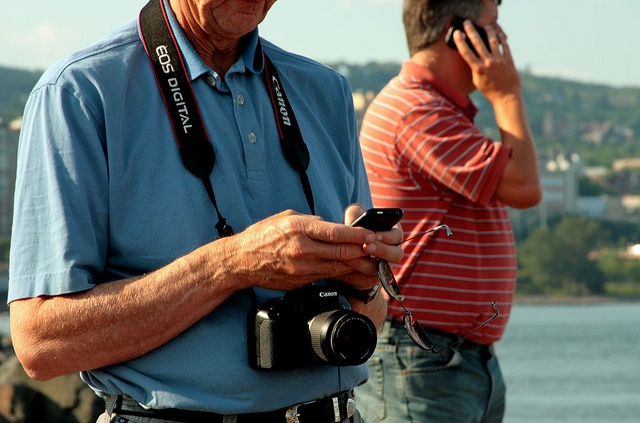Describe the objects in this image and their specific colors. I can see people in ivory, blue, black, maroon, and darkblue tones, people in ivory, maroon, black, gray, and salmon tones, cell phone in ivory, black, maroon, gray, and beige tones, and cell phone in ivory, black, maroon, brown, and tan tones in this image. 